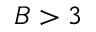Convert formula to latex. <formula><loc_0><loc_0><loc_500><loc_500>B > 3</formula> 